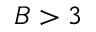Convert formula to latex. <formula><loc_0><loc_0><loc_500><loc_500>B > 3</formula> 